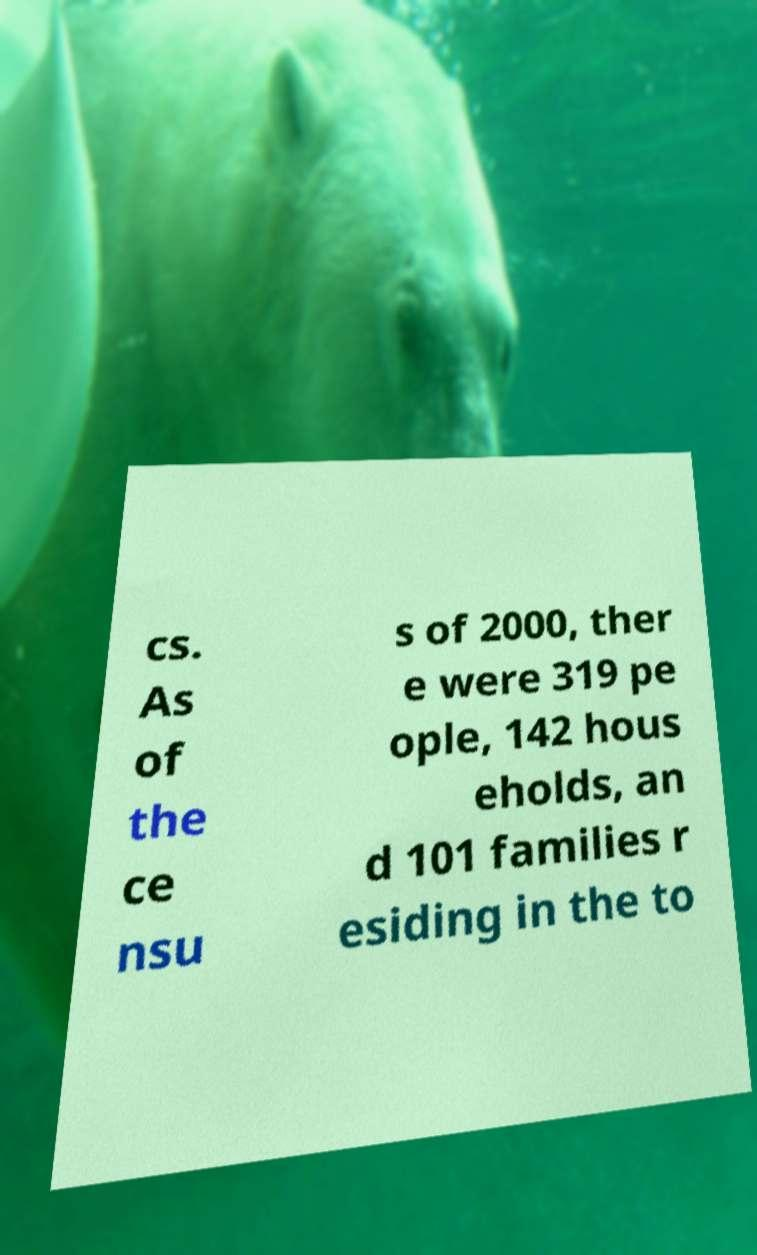For documentation purposes, I need the text within this image transcribed. Could you provide that? cs. As of the ce nsu s of 2000, ther e were 319 pe ople, 142 hous eholds, an d 101 families r esiding in the to 